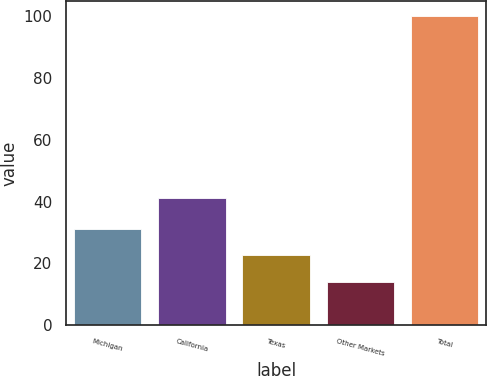Convert chart. <chart><loc_0><loc_0><loc_500><loc_500><bar_chart><fcel>Michigan<fcel>California<fcel>Texas<fcel>Other Markets<fcel>Total<nl><fcel>31.2<fcel>41<fcel>22.6<fcel>14<fcel>100<nl></chart> 